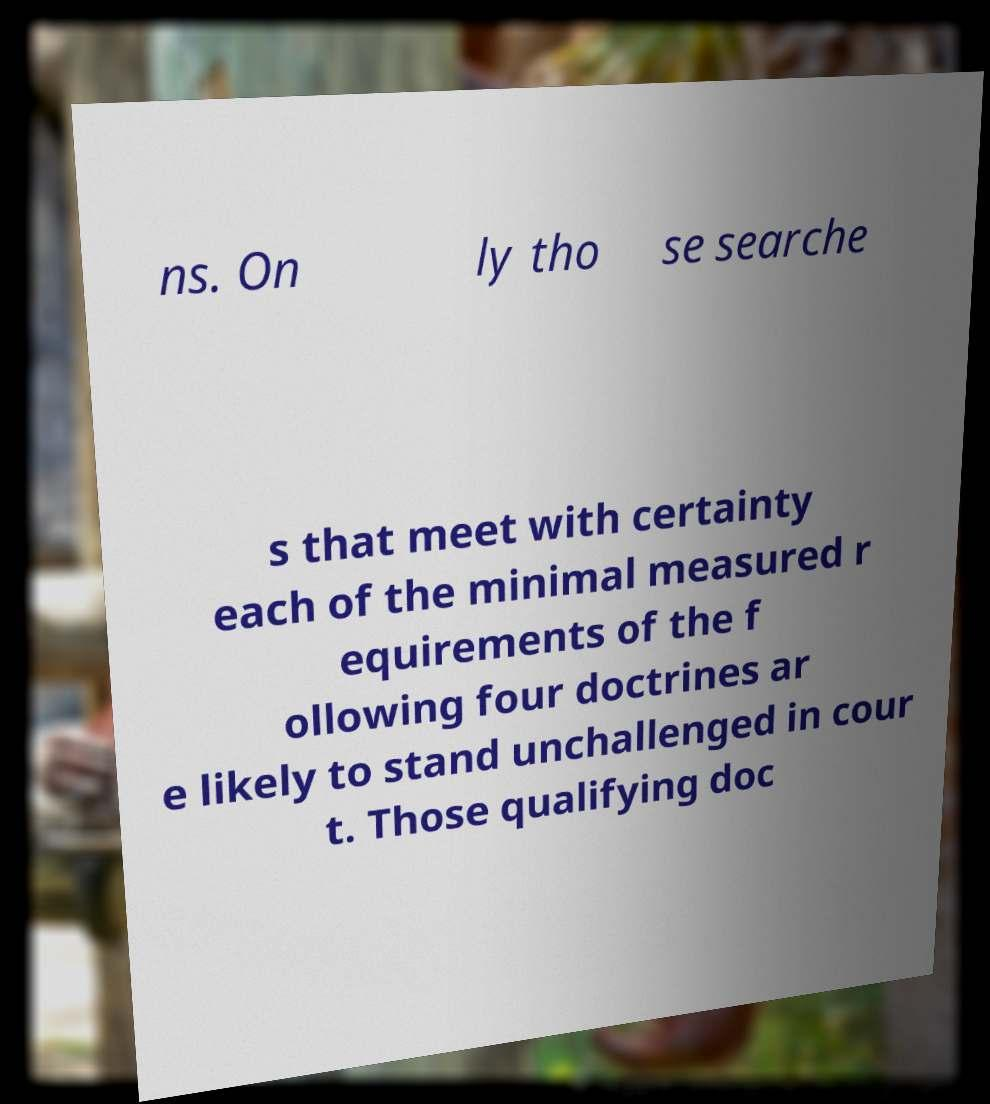Please identify and transcribe the text found in this image. ns. On ly tho se searche s that meet with certainty each of the minimal measured r equirements of the f ollowing four doctrines ar e likely to stand unchallenged in cour t. Those qualifying doc 